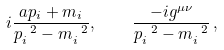Convert formula to latex. <formula><loc_0><loc_0><loc_500><loc_500>i \frac { \sl a { p } _ { i } + m _ { i } } { p _ { i } ^ { \ 2 } - m _ { i } ^ { \ 2 } } , \quad \frac { - i g ^ { \mu \nu } } { p _ { i } ^ { \ 2 } - m _ { i } ^ { \ 2 } } \, ,</formula> 